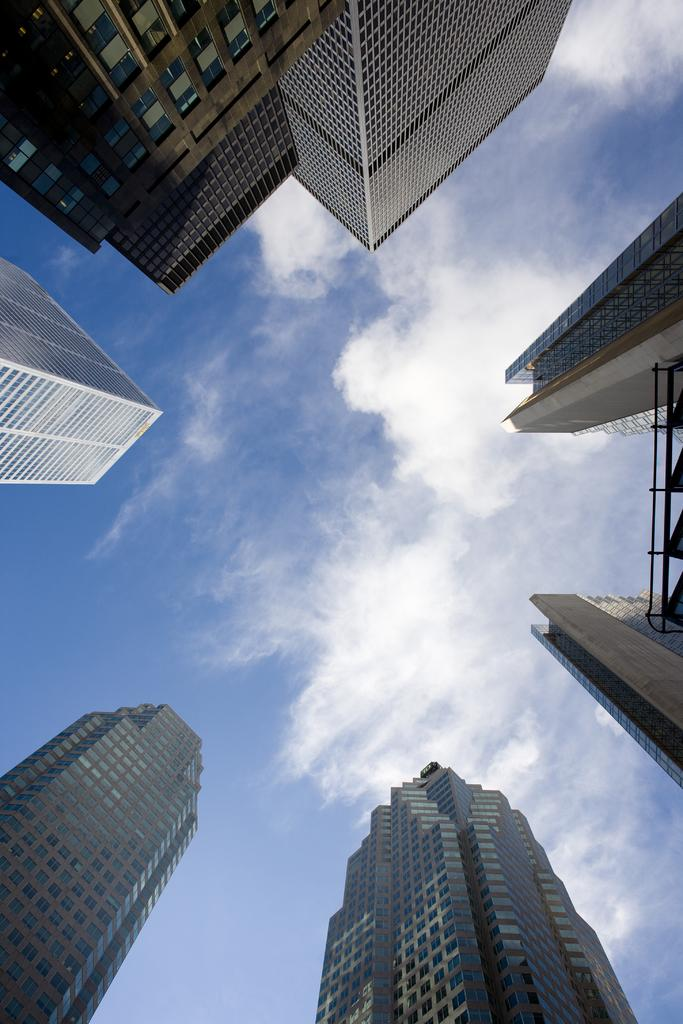What type of structures can be seen in the image? There are buildings in the image. What part of the natural environment is visible in the image? The sky is visible in the image. What can be observed in the sky? Clouds are present in the sky. What type of pancake is being served at the division in the image? There is no pancake or division present in the image; it features buildings and clouds in the sky. 